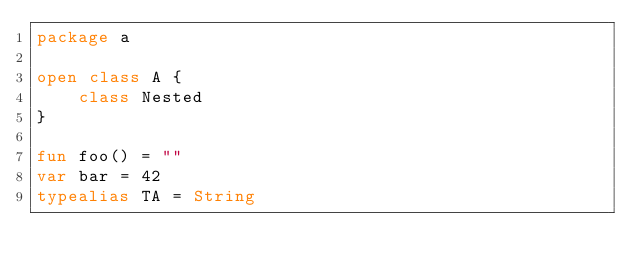Convert code to text. <code><loc_0><loc_0><loc_500><loc_500><_Kotlin_>package a

open class A {
    class Nested
}

fun foo() = ""
var bar = 42
typealias TA = String
</code> 